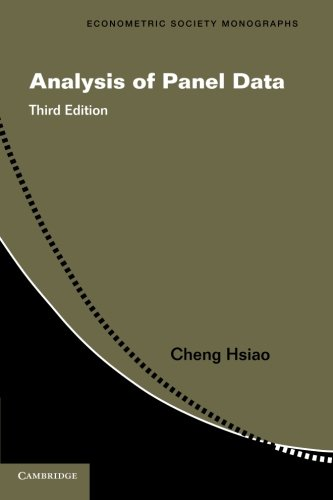What specific econometric techniques are discussed in this book? This book covers a range of techniques important in the analysis of panel data, including fixed effects models, random effects models, and dynamic panel data methods, among others. 